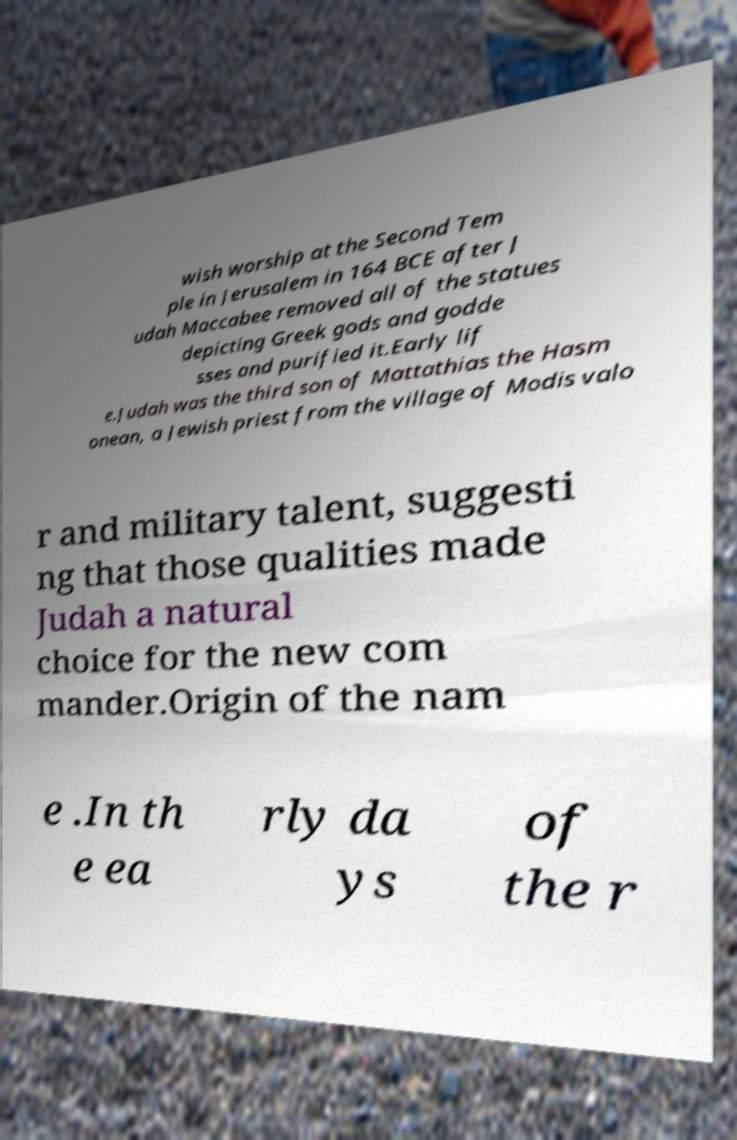I need the written content from this picture converted into text. Can you do that? wish worship at the Second Tem ple in Jerusalem in 164 BCE after J udah Maccabee removed all of the statues depicting Greek gods and godde sses and purified it.Early lif e.Judah was the third son of Mattathias the Hasm onean, a Jewish priest from the village of Modis valo r and military talent, suggesti ng that those qualities made Judah a natural choice for the new com mander.Origin of the nam e .In th e ea rly da ys of the r 